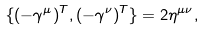<formula> <loc_0><loc_0><loc_500><loc_500>\{ ( - \gamma ^ { \mu } ) ^ { T } , ( - \gamma ^ { \nu } ) ^ { T } \} = 2 \eta ^ { \mu \nu } ,</formula> 